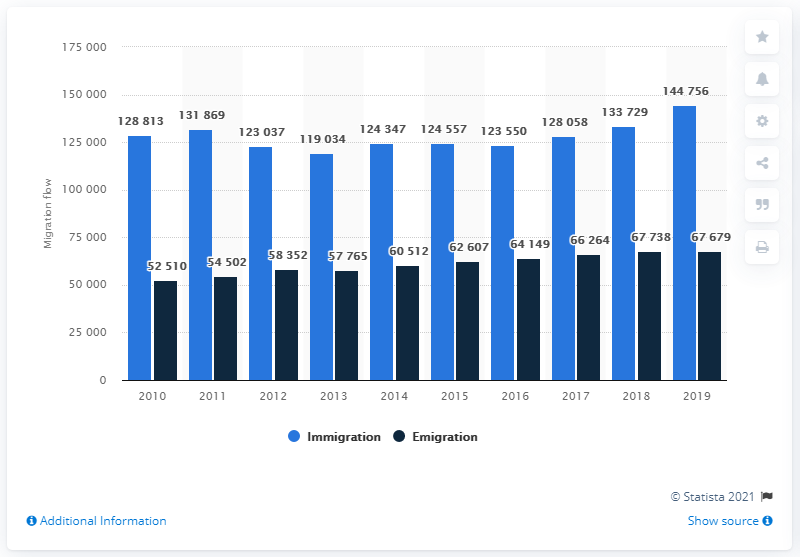Point out several critical features in this image. In 2019, 144,756 people migrated to Belgium. 